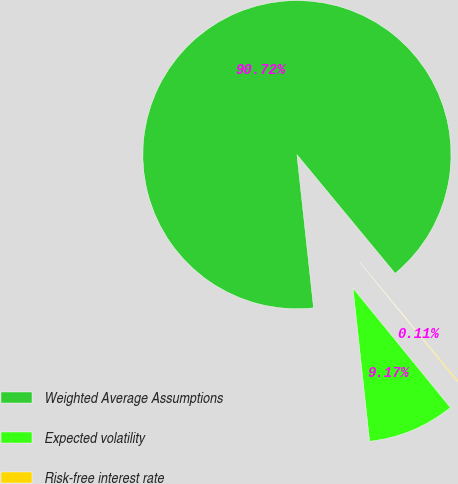<chart> <loc_0><loc_0><loc_500><loc_500><pie_chart><fcel>Weighted Average Assumptions<fcel>Expected volatility<fcel>Risk-free interest rate<nl><fcel>90.72%<fcel>9.17%<fcel>0.11%<nl></chart> 